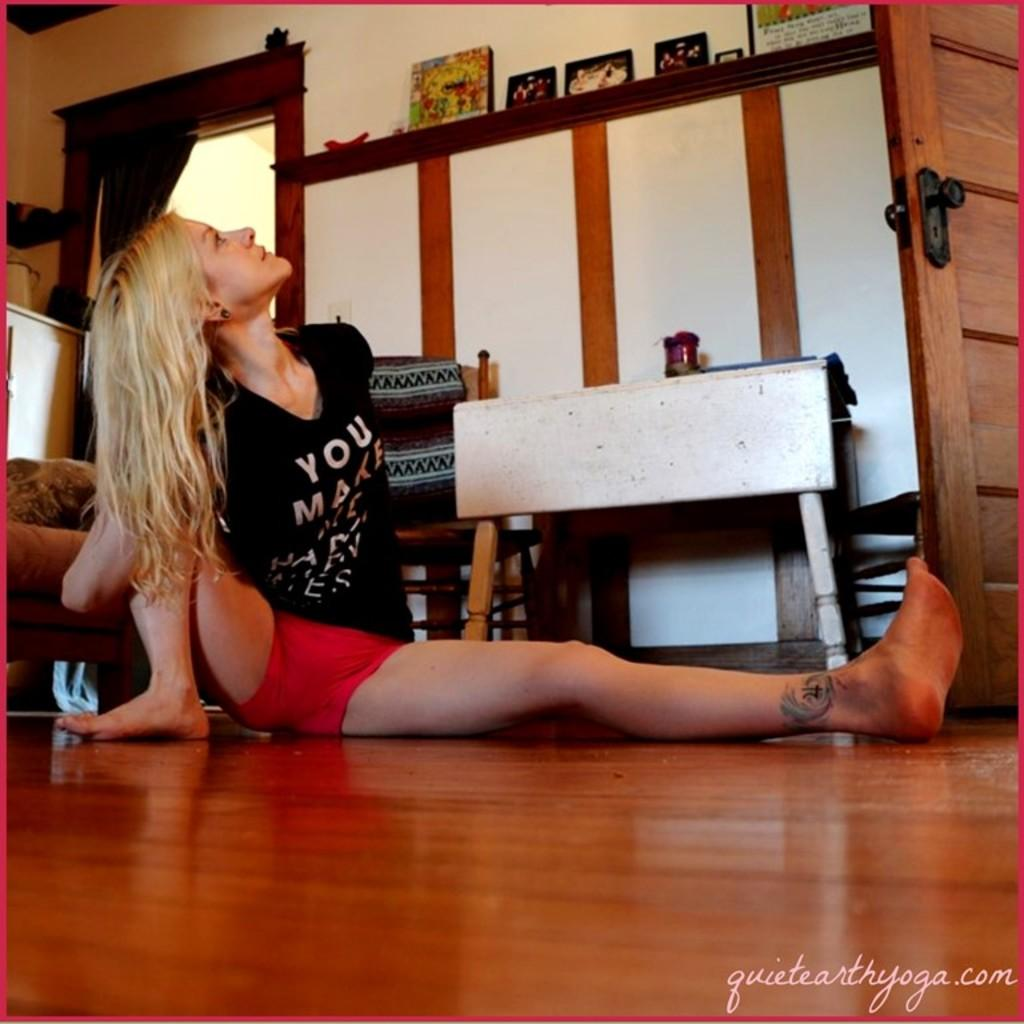<image>
Render a clear and concise summary of the photo. A black shirted woman is posing for a picture with a logo for quiet earth yoga on the bottom right. 